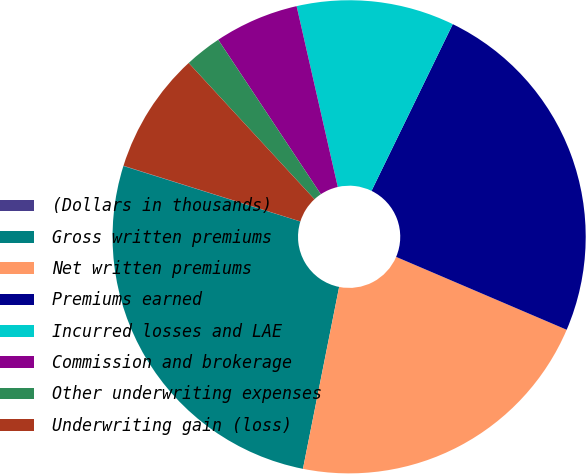<chart> <loc_0><loc_0><loc_500><loc_500><pie_chart><fcel>(Dollars in thousands)<fcel>Gross written premiums<fcel>Net written premiums<fcel>Premiums earned<fcel>Incurred losses and LAE<fcel>Commission and brokerage<fcel>Other underwriting expenses<fcel>Underwriting gain (loss)<nl><fcel>0.02%<fcel>26.71%<fcel>21.7%<fcel>24.21%<fcel>10.78%<fcel>5.77%<fcel>2.53%<fcel>8.28%<nl></chart> 